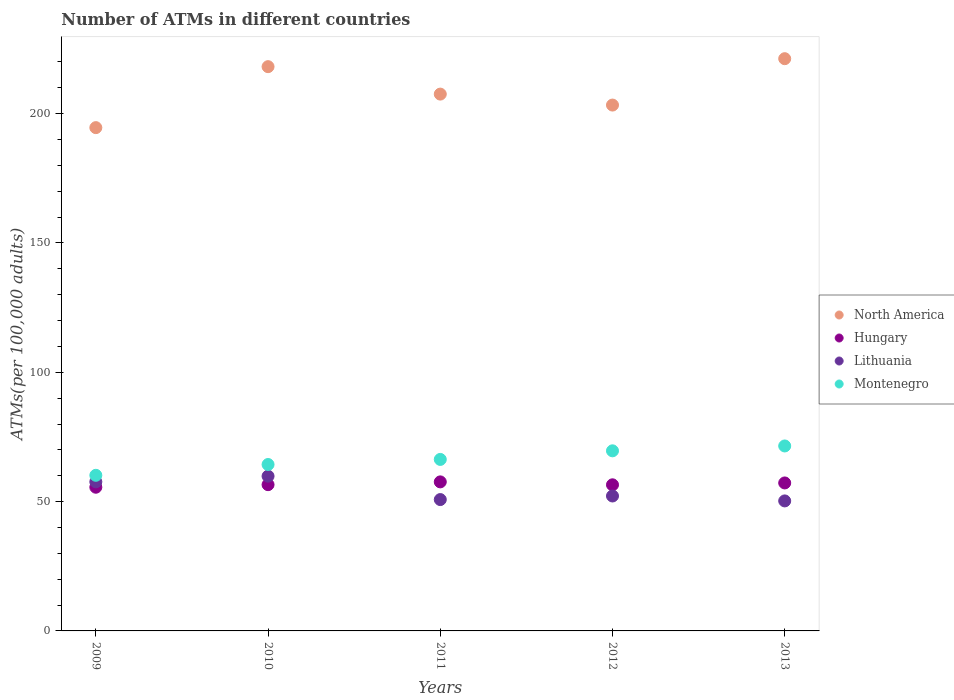What is the number of ATMs in Hungary in 2012?
Provide a succinct answer. 56.49. Across all years, what is the maximum number of ATMs in Hungary?
Keep it short and to the point. 57.63. Across all years, what is the minimum number of ATMs in Lithuania?
Offer a terse response. 50.27. In which year was the number of ATMs in Montenegro maximum?
Your answer should be very brief. 2013. In which year was the number of ATMs in Hungary minimum?
Provide a short and direct response. 2009. What is the total number of ATMs in Lithuania in the graph?
Offer a terse response. 270.72. What is the difference between the number of ATMs in North America in 2009 and that in 2010?
Keep it short and to the point. -23.58. What is the difference between the number of ATMs in Lithuania in 2010 and the number of ATMs in Hungary in 2009?
Make the answer very short. 4.28. What is the average number of ATMs in Lithuania per year?
Give a very brief answer. 54.14. In the year 2011, what is the difference between the number of ATMs in Montenegro and number of ATMs in North America?
Offer a terse response. -141.25. What is the ratio of the number of ATMs in Hungary in 2011 to that in 2012?
Offer a very short reply. 1.02. What is the difference between the highest and the second highest number of ATMs in North America?
Provide a short and direct response. 3.08. What is the difference between the highest and the lowest number of ATMs in Hungary?
Your answer should be compact. 2.07. In how many years, is the number of ATMs in Montenegro greater than the average number of ATMs in Montenegro taken over all years?
Make the answer very short. 2. Is the sum of the number of ATMs in Hungary in 2009 and 2012 greater than the maximum number of ATMs in Montenegro across all years?
Your answer should be compact. Yes. Is it the case that in every year, the sum of the number of ATMs in Lithuania and number of ATMs in Hungary  is greater than the number of ATMs in North America?
Offer a very short reply. No. Is the number of ATMs in North America strictly less than the number of ATMs in Montenegro over the years?
Ensure brevity in your answer.  No. How many dotlines are there?
Your answer should be compact. 4. Are the values on the major ticks of Y-axis written in scientific E-notation?
Offer a terse response. No. Does the graph contain any zero values?
Your answer should be very brief. No. How many legend labels are there?
Your response must be concise. 4. What is the title of the graph?
Ensure brevity in your answer.  Number of ATMs in different countries. Does "Madagascar" appear as one of the legend labels in the graph?
Your answer should be very brief. No. What is the label or title of the Y-axis?
Offer a very short reply. ATMs(per 100,0 adults). What is the ATMs(per 100,000 adults) in North America in 2009?
Provide a short and direct response. 194.6. What is the ATMs(per 100,000 adults) in Hungary in 2009?
Your answer should be compact. 55.56. What is the ATMs(per 100,000 adults) in Lithuania in 2009?
Make the answer very short. 57.65. What is the ATMs(per 100,000 adults) in Montenegro in 2009?
Provide a succinct answer. 60.17. What is the ATMs(per 100,000 adults) in North America in 2010?
Your response must be concise. 218.18. What is the ATMs(per 100,000 adults) of Hungary in 2010?
Your answer should be very brief. 56.55. What is the ATMs(per 100,000 adults) in Lithuania in 2010?
Give a very brief answer. 59.84. What is the ATMs(per 100,000 adults) of Montenegro in 2010?
Give a very brief answer. 64.35. What is the ATMs(per 100,000 adults) of North America in 2011?
Keep it short and to the point. 207.56. What is the ATMs(per 100,000 adults) of Hungary in 2011?
Give a very brief answer. 57.63. What is the ATMs(per 100,000 adults) of Lithuania in 2011?
Your response must be concise. 50.79. What is the ATMs(per 100,000 adults) of Montenegro in 2011?
Keep it short and to the point. 66.31. What is the ATMs(per 100,000 adults) of North America in 2012?
Make the answer very short. 203.33. What is the ATMs(per 100,000 adults) in Hungary in 2012?
Your answer should be compact. 56.49. What is the ATMs(per 100,000 adults) in Lithuania in 2012?
Your response must be concise. 52.17. What is the ATMs(per 100,000 adults) in Montenegro in 2012?
Offer a very short reply. 69.64. What is the ATMs(per 100,000 adults) in North America in 2013?
Keep it short and to the point. 221.26. What is the ATMs(per 100,000 adults) of Hungary in 2013?
Your answer should be compact. 57.22. What is the ATMs(per 100,000 adults) of Lithuania in 2013?
Offer a terse response. 50.27. What is the ATMs(per 100,000 adults) of Montenegro in 2013?
Make the answer very short. 71.52. Across all years, what is the maximum ATMs(per 100,000 adults) of North America?
Offer a terse response. 221.26. Across all years, what is the maximum ATMs(per 100,000 adults) in Hungary?
Ensure brevity in your answer.  57.63. Across all years, what is the maximum ATMs(per 100,000 adults) in Lithuania?
Make the answer very short. 59.84. Across all years, what is the maximum ATMs(per 100,000 adults) in Montenegro?
Offer a very short reply. 71.52. Across all years, what is the minimum ATMs(per 100,000 adults) of North America?
Offer a very short reply. 194.6. Across all years, what is the minimum ATMs(per 100,000 adults) of Hungary?
Keep it short and to the point. 55.56. Across all years, what is the minimum ATMs(per 100,000 adults) of Lithuania?
Ensure brevity in your answer.  50.27. Across all years, what is the minimum ATMs(per 100,000 adults) in Montenegro?
Offer a terse response. 60.17. What is the total ATMs(per 100,000 adults) of North America in the graph?
Provide a short and direct response. 1044.92. What is the total ATMs(per 100,000 adults) of Hungary in the graph?
Make the answer very short. 283.45. What is the total ATMs(per 100,000 adults) of Lithuania in the graph?
Provide a succinct answer. 270.72. What is the total ATMs(per 100,000 adults) in Montenegro in the graph?
Your answer should be compact. 331.98. What is the difference between the ATMs(per 100,000 adults) of North America in 2009 and that in 2010?
Your answer should be compact. -23.58. What is the difference between the ATMs(per 100,000 adults) in Hungary in 2009 and that in 2010?
Provide a succinct answer. -0.99. What is the difference between the ATMs(per 100,000 adults) in Lithuania in 2009 and that in 2010?
Ensure brevity in your answer.  -2.19. What is the difference between the ATMs(per 100,000 adults) of Montenegro in 2009 and that in 2010?
Make the answer very short. -4.18. What is the difference between the ATMs(per 100,000 adults) in North America in 2009 and that in 2011?
Provide a succinct answer. -12.96. What is the difference between the ATMs(per 100,000 adults) in Hungary in 2009 and that in 2011?
Offer a very short reply. -2.07. What is the difference between the ATMs(per 100,000 adults) of Lithuania in 2009 and that in 2011?
Keep it short and to the point. 6.86. What is the difference between the ATMs(per 100,000 adults) of Montenegro in 2009 and that in 2011?
Make the answer very short. -6.14. What is the difference between the ATMs(per 100,000 adults) of North America in 2009 and that in 2012?
Keep it short and to the point. -8.73. What is the difference between the ATMs(per 100,000 adults) in Hungary in 2009 and that in 2012?
Give a very brief answer. -0.93. What is the difference between the ATMs(per 100,000 adults) of Lithuania in 2009 and that in 2012?
Provide a succinct answer. 5.48. What is the difference between the ATMs(per 100,000 adults) in Montenegro in 2009 and that in 2012?
Your answer should be compact. -9.47. What is the difference between the ATMs(per 100,000 adults) in North America in 2009 and that in 2013?
Keep it short and to the point. -26.66. What is the difference between the ATMs(per 100,000 adults) in Hungary in 2009 and that in 2013?
Keep it short and to the point. -1.66. What is the difference between the ATMs(per 100,000 adults) in Lithuania in 2009 and that in 2013?
Keep it short and to the point. 7.38. What is the difference between the ATMs(per 100,000 adults) of Montenegro in 2009 and that in 2013?
Ensure brevity in your answer.  -11.35. What is the difference between the ATMs(per 100,000 adults) of North America in 2010 and that in 2011?
Provide a succinct answer. 10.61. What is the difference between the ATMs(per 100,000 adults) of Hungary in 2010 and that in 2011?
Your response must be concise. -1.08. What is the difference between the ATMs(per 100,000 adults) in Lithuania in 2010 and that in 2011?
Offer a very short reply. 9.05. What is the difference between the ATMs(per 100,000 adults) in Montenegro in 2010 and that in 2011?
Offer a very short reply. -1.96. What is the difference between the ATMs(per 100,000 adults) of North America in 2010 and that in 2012?
Your answer should be compact. 14.85. What is the difference between the ATMs(per 100,000 adults) in Hungary in 2010 and that in 2012?
Your response must be concise. 0.06. What is the difference between the ATMs(per 100,000 adults) of Lithuania in 2010 and that in 2012?
Keep it short and to the point. 7.66. What is the difference between the ATMs(per 100,000 adults) in Montenegro in 2010 and that in 2012?
Provide a succinct answer. -5.29. What is the difference between the ATMs(per 100,000 adults) in North America in 2010 and that in 2013?
Your answer should be very brief. -3.08. What is the difference between the ATMs(per 100,000 adults) in Hungary in 2010 and that in 2013?
Ensure brevity in your answer.  -0.67. What is the difference between the ATMs(per 100,000 adults) in Lithuania in 2010 and that in 2013?
Your answer should be compact. 9.57. What is the difference between the ATMs(per 100,000 adults) in Montenegro in 2010 and that in 2013?
Keep it short and to the point. -7.17. What is the difference between the ATMs(per 100,000 adults) of North America in 2011 and that in 2012?
Offer a terse response. 4.24. What is the difference between the ATMs(per 100,000 adults) of Hungary in 2011 and that in 2012?
Make the answer very short. 1.13. What is the difference between the ATMs(per 100,000 adults) of Lithuania in 2011 and that in 2012?
Your answer should be very brief. -1.38. What is the difference between the ATMs(per 100,000 adults) in Montenegro in 2011 and that in 2012?
Give a very brief answer. -3.32. What is the difference between the ATMs(per 100,000 adults) of North America in 2011 and that in 2013?
Offer a terse response. -13.7. What is the difference between the ATMs(per 100,000 adults) of Hungary in 2011 and that in 2013?
Your response must be concise. 0.41. What is the difference between the ATMs(per 100,000 adults) in Lithuania in 2011 and that in 2013?
Give a very brief answer. 0.52. What is the difference between the ATMs(per 100,000 adults) in Montenegro in 2011 and that in 2013?
Give a very brief answer. -5.21. What is the difference between the ATMs(per 100,000 adults) in North America in 2012 and that in 2013?
Provide a short and direct response. -17.93. What is the difference between the ATMs(per 100,000 adults) of Hungary in 2012 and that in 2013?
Offer a terse response. -0.72. What is the difference between the ATMs(per 100,000 adults) in Lithuania in 2012 and that in 2013?
Give a very brief answer. 1.91. What is the difference between the ATMs(per 100,000 adults) in Montenegro in 2012 and that in 2013?
Provide a short and direct response. -1.88. What is the difference between the ATMs(per 100,000 adults) in North America in 2009 and the ATMs(per 100,000 adults) in Hungary in 2010?
Your response must be concise. 138.05. What is the difference between the ATMs(per 100,000 adults) of North America in 2009 and the ATMs(per 100,000 adults) of Lithuania in 2010?
Offer a terse response. 134.76. What is the difference between the ATMs(per 100,000 adults) in North America in 2009 and the ATMs(per 100,000 adults) in Montenegro in 2010?
Provide a succinct answer. 130.25. What is the difference between the ATMs(per 100,000 adults) of Hungary in 2009 and the ATMs(per 100,000 adults) of Lithuania in 2010?
Your response must be concise. -4.28. What is the difference between the ATMs(per 100,000 adults) in Hungary in 2009 and the ATMs(per 100,000 adults) in Montenegro in 2010?
Your answer should be very brief. -8.79. What is the difference between the ATMs(per 100,000 adults) in Lithuania in 2009 and the ATMs(per 100,000 adults) in Montenegro in 2010?
Offer a terse response. -6.7. What is the difference between the ATMs(per 100,000 adults) in North America in 2009 and the ATMs(per 100,000 adults) in Hungary in 2011?
Make the answer very short. 136.97. What is the difference between the ATMs(per 100,000 adults) in North America in 2009 and the ATMs(per 100,000 adults) in Lithuania in 2011?
Offer a terse response. 143.81. What is the difference between the ATMs(per 100,000 adults) in North America in 2009 and the ATMs(per 100,000 adults) in Montenegro in 2011?
Your answer should be very brief. 128.29. What is the difference between the ATMs(per 100,000 adults) in Hungary in 2009 and the ATMs(per 100,000 adults) in Lithuania in 2011?
Provide a short and direct response. 4.77. What is the difference between the ATMs(per 100,000 adults) in Hungary in 2009 and the ATMs(per 100,000 adults) in Montenegro in 2011?
Keep it short and to the point. -10.75. What is the difference between the ATMs(per 100,000 adults) in Lithuania in 2009 and the ATMs(per 100,000 adults) in Montenegro in 2011?
Your answer should be compact. -8.66. What is the difference between the ATMs(per 100,000 adults) of North America in 2009 and the ATMs(per 100,000 adults) of Hungary in 2012?
Make the answer very short. 138.1. What is the difference between the ATMs(per 100,000 adults) in North America in 2009 and the ATMs(per 100,000 adults) in Lithuania in 2012?
Ensure brevity in your answer.  142.43. What is the difference between the ATMs(per 100,000 adults) in North America in 2009 and the ATMs(per 100,000 adults) in Montenegro in 2012?
Your answer should be very brief. 124.96. What is the difference between the ATMs(per 100,000 adults) of Hungary in 2009 and the ATMs(per 100,000 adults) of Lithuania in 2012?
Keep it short and to the point. 3.39. What is the difference between the ATMs(per 100,000 adults) in Hungary in 2009 and the ATMs(per 100,000 adults) in Montenegro in 2012?
Your response must be concise. -14.08. What is the difference between the ATMs(per 100,000 adults) of Lithuania in 2009 and the ATMs(per 100,000 adults) of Montenegro in 2012?
Ensure brevity in your answer.  -11.99. What is the difference between the ATMs(per 100,000 adults) of North America in 2009 and the ATMs(per 100,000 adults) of Hungary in 2013?
Give a very brief answer. 137.38. What is the difference between the ATMs(per 100,000 adults) of North America in 2009 and the ATMs(per 100,000 adults) of Lithuania in 2013?
Your answer should be compact. 144.33. What is the difference between the ATMs(per 100,000 adults) in North America in 2009 and the ATMs(per 100,000 adults) in Montenegro in 2013?
Keep it short and to the point. 123.08. What is the difference between the ATMs(per 100,000 adults) in Hungary in 2009 and the ATMs(per 100,000 adults) in Lithuania in 2013?
Make the answer very short. 5.29. What is the difference between the ATMs(per 100,000 adults) in Hungary in 2009 and the ATMs(per 100,000 adults) in Montenegro in 2013?
Make the answer very short. -15.96. What is the difference between the ATMs(per 100,000 adults) of Lithuania in 2009 and the ATMs(per 100,000 adults) of Montenegro in 2013?
Keep it short and to the point. -13.87. What is the difference between the ATMs(per 100,000 adults) of North America in 2010 and the ATMs(per 100,000 adults) of Hungary in 2011?
Keep it short and to the point. 160.55. What is the difference between the ATMs(per 100,000 adults) of North America in 2010 and the ATMs(per 100,000 adults) of Lithuania in 2011?
Offer a terse response. 167.39. What is the difference between the ATMs(per 100,000 adults) in North America in 2010 and the ATMs(per 100,000 adults) in Montenegro in 2011?
Your response must be concise. 151.87. What is the difference between the ATMs(per 100,000 adults) in Hungary in 2010 and the ATMs(per 100,000 adults) in Lithuania in 2011?
Your response must be concise. 5.76. What is the difference between the ATMs(per 100,000 adults) in Hungary in 2010 and the ATMs(per 100,000 adults) in Montenegro in 2011?
Ensure brevity in your answer.  -9.76. What is the difference between the ATMs(per 100,000 adults) of Lithuania in 2010 and the ATMs(per 100,000 adults) of Montenegro in 2011?
Your answer should be compact. -6.48. What is the difference between the ATMs(per 100,000 adults) of North America in 2010 and the ATMs(per 100,000 adults) of Hungary in 2012?
Make the answer very short. 161.68. What is the difference between the ATMs(per 100,000 adults) of North America in 2010 and the ATMs(per 100,000 adults) of Lithuania in 2012?
Your answer should be compact. 166. What is the difference between the ATMs(per 100,000 adults) of North America in 2010 and the ATMs(per 100,000 adults) of Montenegro in 2012?
Offer a very short reply. 148.54. What is the difference between the ATMs(per 100,000 adults) of Hungary in 2010 and the ATMs(per 100,000 adults) of Lithuania in 2012?
Your response must be concise. 4.38. What is the difference between the ATMs(per 100,000 adults) in Hungary in 2010 and the ATMs(per 100,000 adults) in Montenegro in 2012?
Offer a very short reply. -13.09. What is the difference between the ATMs(per 100,000 adults) of Lithuania in 2010 and the ATMs(per 100,000 adults) of Montenegro in 2012?
Your answer should be compact. -9.8. What is the difference between the ATMs(per 100,000 adults) in North America in 2010 and the ATMs(per 100,000 adults) in Hungary in 2013?
Ensure brevity in your answer.  160.96. What is the difference between the ATMs(per 100,000 adults) in North America in 2010 and the ATMs(per 100,000 adults) in Lithuania in 2013?
Offer a very short reply. 167.91. What is the difference between the ATMs(per 100,000 adults) in North America in 2010 and the ATMs(per 100,000 adults) in Montenegro in 2013?
Your answer should be very brief. 146.66. What is the difference between the ATMs(per 100,000 adults) in Hungary in 2010 and the ATMs(per 100,000 adults) in Lithuania in 2013?
Offer a very short reply. 6.28. What is the difference between the ATMs(per 100,000 adults) in Hungary in 2010 and the ATMs(per 100,000 adults) in Montenegro in 2013?
Offer a very short reply. -14.97. What is the difference between the ATMs(per 100,000 adults) in Lithuania in 2010 and the ATMs(per 100,000 adults) in Montenegro in 2013?
Your answer should be very brief. -11.68. What is the difference between the ATMs(per 100,000 adults) of North America in 2011 and the ATMs(per 100,000 adults) of Hungary in 2012?
Provide a succinct answer. 151.07. What is the difference between the ATMs(per 100,000 adults) of North America in 2011 and the ATMs(per 100,000 adults) of Lithuania in 2012?
Ensure brevity in your answer.  155.39. What is the difference between the ATMs(per 100,000 adults) of North America in 2011 and the ATMs(per 100,000 adults) of Montenegro in 2012?
Ensure brevity in your answer.  137.93. What is the difference between the ATMs(per 100,000 adults) of Hungary in 2011 and the ATMs(per 100,000 adults) of Lithuania in 2012?
Your response must be concise. 5.45. What is the difference between the ATMs(per 100,000 adults) in Hungary in 2011 and the ATMs(per 100,000 adults) in Montenegro in 2012?
Offer a very short reply. -12.01. What is the difference between the ATMs(per 100,000 adults) in Lithuania in 2011 and the ATMs(per 100,000 adults) in Montenegro in 2012?
Your answer should be compact. -18.85. What is the difference between the ATMs(per 100,000 adults) of North America in 2011 and the ATMs(per 100,000 adults) of Hungary in 2013?
Offer a terse response. 150.35. What is the difference between the ATMs(per 100,000 adults) of North America in 2011 and the ATMs(per 100,000 adults) of Lithuania in 2013?
Provide a short and direct response. 157.3. What is the difference between the ATMs(per 100,000 adults) of North America in 2011 and the ATMs(per 100,000 adults) of Montenegro in 2013?
Provide a short and direct response. 136.04. What is the difference between the ATMs(per 100,000 adults) of Hungary in 2011 and the ATMs(per 100,000 adults) of Lithuania in 2013?
Ensure brevity in your answer.  7.36. What is the difference between the ATMs(per 100,000 adults) of Hungary in 2011 and the ATMs(per 100,000 adults) of Montenegro in 2013?
Make the answer very short. -13.89. What is the difference between the ATMs(per 100,000 adults) of Lithuania in 2011 and the ATMs(per 100,000 adults) of Montenegro in 2013?
Make the answer very short. -20.73. What is the difference between the ATMs(per 100,000 adults) in North America in 2012 and the ATMs(per 100,000 adults) in Hungary in 2013?
Make the answer very short. 146.11. What is the difference between the ATMs(per 100,000 adults) in North America in 2012 and the ATMs(per 100,000 adults) in Lithuania in 2013?
Offer a terse response. 153.06. What is the difference between the ATMs(per 100,000 adults) of North America in 2012 and the ATMs(per 100,000 adults) of Montenegro in 2013?
Provide a short and direct response. 131.81. What is the difference between the ATMs(per 100,000 adults) in Hungary in 2012 and the ATMs(per 100,000 adults) in Lithuania in 2013?
Offer a very short reply. 6.23. What is the difference between the ATMs(per 100,000 adults) in Hungary in 2012 and the ATMs(per 100,000 adults) in Montenegro in 2013?
Provide a short and direct response. -15.02. What is the difference between the ATMs(per 100,000 adults) of Lithuania in 2012 and the ATMs(per 100,000 adults) of Montenegro in 2013?
Your answer should be compact. -19.34. What is the average ATMs(per 100,000 adults) in North America per year?
Your response must be concise. 208.98. What is the average ATMs(per 100,000 adults) of Hungary per year?
Make the answer very short. 56.69. What is the average ATMs(per 100,000 adults) in Lithuania per year?
Ensure brevity in your answer.  54.14. What is the average ATMs(per 100,000 adults) of Montenegro per year?
Your answer should be very brief. 66.4. In the year 2009, what is the difference between the ATMs(per 100,000 adults) of North America and ATMs(per 100,000 adults) of Hungary?
Make the answer very short. 139.04. In the year 2009, what is the difference between the ATMs(per 100,000 adults) in North America and ATMs(per 100,000 adults) in Lithuania?
Give a very brief answer. 136.95. In the year 2009, what is the difference between the ATMs(per 100,000 adults) in North America and ATMs(per 100,000 adults) in Montenegro?
Offer a very short reply. 134.43. In the year 2009, what is the difference between the ATMs(per 100,000 adults) in Hungary and ATMs(per 100,000 adults) in Lithuania?
Your answer should be compact. -2.09. In the year 2009, what is the difference between the ATMs(per 100,000 adults) of Hungary and ATMs(per 100,000 adults) of Montenegro?
Offer a terse response. -4.61. In the year 2009, what is the difference between the ATMs(per 100,000 adults) in Lithuania and ATMs(per 100,000 adults) in Montenegro?
Give a very brief answer. -2.52. In the year 2010, what is the difference between the ATMs(per 100,000 adults) in North America and ATMs(per 100,000 adults) in Hungary?
Keep it short and to the point. 161.63. In the year 2010, what is the difference between the ATMs(per 100,000 adults) in North America and ATMs(per 100,000 adults) in Lithuania?
Your answer should be compact. 158.34. In the year 2010, what is the difference between the ATMs(per 100,000 adults) of North America and ATMs(per 100,000 adults) of Montenegro?
Your answer should be very brief. 153.83. In the year 2010, what is the difference between the ATMs(per 100,000 adults) of Hungary and ATMs(per 100,000 adults) of Lithuania?
Ensure brevity in your answer.  -3.28. In the year 2010, what is the difference between the ATMs(per 100,000 adults) of Hungary and ATMs(per 100,000 adults) of Montenegro?
Provide a succinct answer. -7.8. In the year 2010, what is the difference between the ATMs(per 100,000 adults) in Lithuania and ATMs(per 100,000 adults) in Montenegro?
Your response must be concise. -4.51. In the year 2011, what is the difference between the ATMs(per 100,000 adults) of North America and ATMs(per 100,000 adults) of Hungary?
Give a very brief answer. 149.94. In the year 2011, what is the difference between the ATMs(per 100,000 adults) of North America and ATMs(per 100,000 adults) of Lithuania?
Ensure brevity in your answer.  156.77. In the year 2011, what is the difference between the ATMs(per 100,000 adults) in North America and ATMs(per 100,000 adults) in Montenegro?
Provide a succinct answer. 141.25. In the year 2011, what is the difference between the ATMs(per 100,000 adults) in Hungary and ATMs(per 100,000 adults) in Lithuania?
Your answer should be very brief. 6.84. In the year 2011, what is the difference between the ATMs(per 100,000 adults) of Hungary and ATMs(per 100,000 adults) of Montenegro?
Your response must be concise. -8.68. In the year 2011, what is the difference between the ATMs(per 100,000 adults) in Lithuania and ATMs(per 100,000 adults) in Montenegro?
Offer a terse response. -15.52. In the year 2012, what is the difference between the ATMs(per 100,000 adults) of North America and ATMs(per 100,000 adults) of Hungary?
Your answer should be compact. 146.83. In the year 2012, what is the difference between the ATMs(per 100,000 adults) in North America and ATMs(per 100,000 adults) in Lithuania?
Your answer should be compact. 151.15. In the year 2012, what is the difference between the ATMs(per 100,000 adults) in North America and ATMs(per 100,000 adults) in Montenegro?
Provide a succinct answer. 133.69. In the year 2012, what is the difference between the ATMs(per 100,000 adults) of Hungary and ATMs(per 100,000 adults) of Lithuania?
Provide a short and direct response. 4.32. In the year 2012, what is the difference between the ATMs(per 100,000 adults) of Hungary and ATMs(per 100,000 adults) of Montenegro?
Your answer should be very brief. -13.14. In the year 2012, what is the difference between the ATMs(per 100,000 adults) in Lithuania and ATMs(per 100,000 adults) in Montenegro?
Your answer should be very brief. -17.46. In the year 2013, what is the difference between the ATMs(per 100,000 adults) in North America and ATMs(per 100,000 adults) in Hungary?
Your answer should be compact. 164.04. In the year 2013, what is the difference between the ATMs(per 100,000 adults) of North America and ATMs(per 100,000 adults) of Lithuania?
Provide a succinct answer. 170.99. In the year 2013, what is the difference between the ATMs(per 100,000 adults) in North America and ATMs(per 100,000 adults) in Montenegro?
Give a very brief answer. 149.74. In the year 2013, what is the difference between the ATMs(per 100,000 adults) of Hungary and ATMs(per 100,000 adults) of Lithuania?
Provide a short and direct response. 6.95. In the year 2013, what is the difference between the ATMs(per 100,000 adults) in Hungary and ATMs(per 100,000 adults) in Montenegro?
Offer a terse response. -14.3. In the year 2013, what is the difference between the ATMs(per 100,000 adults) of Lithuania and ATMs(per 100,000 adults) of Montenegro?
Your answer should be very brief. -21.25. What is the ratio of the ATMs(per 100,000 adults) in North America in 2009 to that in 2010?
Your answer should be very brief. 0.89. What is the ratio of the ATMs(per 100,000 adults) in Hungary in 2009 to that in 2010?
Offer a terse response. 0.98. What is the ratio of the ATMs(per 100,000 adults) of Lithuania in 2009 to that in 2010?
Keep it short and to the point. 0.96. What is the ratio of the ATMs(per 100,000 adults) in Montenegro in 2009 to that in 2010?
Make the answer very short. 0.94. What is the ratio of the ATMs(per 100,000 adults) in Hungary in 2009 to that in 2011?
Offer a very short reply. 0.96. What is the ratio of the ATMs(per 100,000 adults) of Lithuania in 2009 to that in 2011?
Ensure brevity in your answer.  1.14. What is the ratio of the ATMs(per 100,000 adults) of Montenegro in 2009 to that in 2011?
Provide a short and direct response. 0.91. What is the ratio of the ATMs(per 100,000 adults) in North America in 2009 to that in 2012?
Give a very brief answer. 0.96. What is the ratio of the ATMs(per 100,000 adults) in Hungary in 2009 to that in 2012?
Give a very brief answer. 0.98. What is the ratio of the ATMs(per 100,000 adults) of Lithuania in 2009 to that in 2012?
Offer a terse response. 1.1. What is the ratio of the ATMs(per 100,000 adults) in Montenegro in 2009 to that in 2012?
Your answer should be very brief. 0.86. What is the ratio of the ATMs(per 100,000 adults) of North America in 2009 to that in 2013?
Give a very brief answer. 0.88. What is the ratio of the ATMs(per 100,000 adults) of Lithuania in 2009 to that in 2013?
Your answer should be compact. 1.15. What is the ratio of the ATMs(per 100,000 adults) in Montenegro in 2009 to that in 2013?
Provide a succinct answer. 0.84. What is the ratio of the ATMs(per 100,000 adults) in North America in 2010 to that in 2011?
Provide a succinct answer. 1.05. What is the ratio of the ATMs(per 100,000 adults) in Hungary in 2010 to that in 2011?
Offer a very short reply. 0.98. What is the ratio of the ATMs(per 100,000 adults) in Lithuania in 2010 to that in 2011?
Keep it short and to the point. 1.18. What is the ratio of the ATMs(per 100,000 adults) in Montenegro in 2010 to that in 2011?
Your answer should be compact. 0.97. What is the ratio of the ATMs(per 100,000 adults) of North America in 2010 to that in 2012?
Provide a short and direct response. 1.07. What is the ratio of the ATMs(per 100,000 adults) in Lithuania in 2010 to that in 2012?
Ensure brevity in your answer.  1.15. What is the ratio of the ATMs(per 100,000 adults) of Montenegro in 2010 to that in 2012?
Offer a terse response. 0.92. What is the ratio of the ATMs(per 100,000 adults) of North America in 2010 to that in 2013?
Offer a very short reply. 0.99. What is the ratio of the ATMs(per 100,000 adults) of Hungary in 2010 to that in 2013?
Offer a very short reply. 0.99. What is the ratio of the ATMs(per 100,000 adults) in Lithuania in 2010 to that in 2013?
Provide a short and direct response. 1.19. What is the ratio of the ATMs(per 100,000 adults) of Montenegro in 2010 to that in 2013?
Your response must be concise. 0.9. What is the ratio of the ATMs(per 100,000 adults) in North America in 2011 to that in 2012?
Offer a terse response. 1.02. What is the ratio of the ATMs(per 100,000 adults) of Hungary in 2011 to that in 2012?
Make the answer very short. 1.02. What is the ratio of the ATMs(per 100,000 adults) in Lithuania in 2011 to that in 2012?
Your answer should be very brief. 0.97. What is the ratio of the ATMs(per 100,000 adults) of Montenegro in 2011 to that in 2012?
Keep it short and to the point. 0.95. What is the ratio of the ATMs(per 100,000 adults) in North America in 2011 to that in 2013?
Your answer should be very brief. 0.94. What is the ratio of the ATMs(per 100,000 adults) in Hungary in 2011 to that in 2013?
Your response must be concise. 1.01. What is the ratio of the ATMs(per 100,000 adults) in Lithuania in 2011 to that in 2013?
Offer a terse response. 1.01. What is the ratio of the ATMs(per 100,000 adults) of Montenegro in 2011 to that in 2013?
Your response must be concise. 0.93. What is the ratio of the ATMs(per 100,000 adults) of North America in 2012 to that in 2013?
Provide a succinct answer. 0.92. What is the ratio of the ATMs(per 100,000 adults) of Hungary in 2012 to that in 2013?
Make the answer very short. 0.99. What is the ratio of the ATMs(per 100,000 adults) in Lithuania in 2012 to that in 2013?
Ensure brevity in your answer.  1.04. What is the ratio of the ATMs(per 100,000 adults) in Montenegro in 2012 to that in 2013?
Your answer should be very brief. 0.97. What is the difference between the highest and the second highest ATMs(per 100,000 adults) of North America?
Offer a terse response. 3.08. What is the difference between the highest and the second highest ATMs(per 100,000 adults) of Hungary?
Give a very brief answer. 0.41. What is the difference between the highest and the second highest ATMs(per 100,000 adults) in Lithuania?
Keep it short and to the point. 2.19. What is the difference between the highest and the second highest ATMs(per 100,000 adults) of Montenegro?
Your answer should be very brief. 1.88. What is the difference between the highest and the lowest ATMs(per 100,000 adults) in North America?
Your response must be concise. 26.66. What is the difference between the highest and the lowest ATMs(per 100,000 adults) in Hungary?
Give a very brief answer. 2.07. What is the difference between the highest and the lowest ATMs(per 100,000 adults) of Lithuania?
Your answer should be compact. 9.57. What is the difference between the highest and the lowest ATMs(per 100,000 adults) in Montenegro?
Your answer should be very brief. 11.35. 